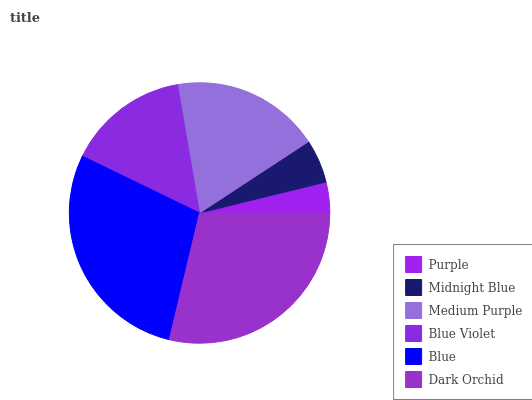Is Purple the minimum?
Answer yes or no. Yes. Is Dark Orchid the maximum?
Answer yes or no. Yes. Is Midnight Blue the minimum?
Answer yes or no. No. Is Midnight Blue the maximum?
Answer yes or no. No. Is Midnight Blue greater than Purple?
Answer yes or no. Yes. Is Purple less than Midnight Blue?
Answer yes or no. Yes. Is Purple greater than Midnight Blue?
Answer yes or no. No. Is Midnight Blue less than Purple?
Answer yes or no. No. Is Medium Purple the high median?
Answer yes or no. Yes. Is Blue Violet the low median?
Answer yes or no. Yes. Is Purple the high median?
Answer yes or no. No. Is Dark Orchid the low median?
Answer yes or no. No. 